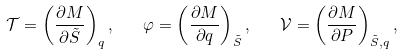Convert formula to latex. <formula><loc_0><loc_0><loc_500><loc_500>\mathcal { T } = \left ( \frac { \partial M } { \partial \tilde { S } } \right ) _ { q } , \quad \varphi = \left ( \frac { \partial M } { \partial q } \right ) _ { \tilde { S } } , \quad \mathcal { V } = \left ( \frac { \partial M } { \partial P } \right ) _ { \tilde { S } , q } ,</formula> 